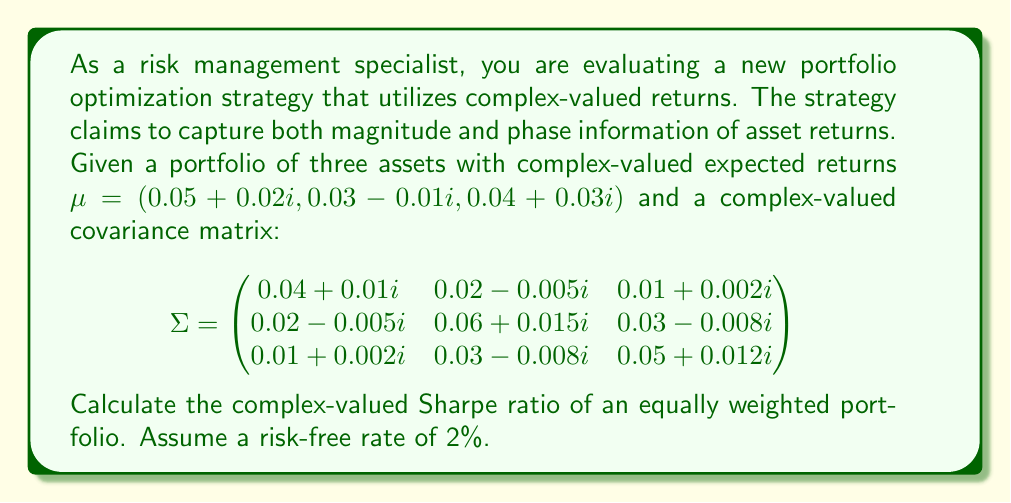Can you answer this question? To solve this problem, we'll follow these steps:

1) First, let's recall the formula for the complex-valued Sharpe ratio:

   $SR = \frac{E[R_p] - R_f}{\sqrt{Var[R_p]}}$

   Where $E[R_p]$ is the expected return of the portfolio, $R_f$ is the risk-free rate, and $Var[R_p]$ is the variance of the portfolio.

2) For an equally weighted portfolio of three assets, the weights are $w = (\frac{1}{3}, \frac{1}{3}, \frac{1}{3})$.

3) Calculate the expected return of the portfolio:
   
   $E[R_p] = w^T \mu = \frac{1}{3}(0.05 + 0.02i) + \frac{1}{3}(0.03 - 0.01i) + \frac{1}{3}(0.04 + 0.03i)$
   
   $E[R_p] = 0.04 + 0.0133i$

4) Calculate the variance of the portfolio:
   
   $Var[R_p] = w^T \Sigma w$

   $Var[R_p] = [\frac{1}{3}, \frac{1}{3}, \frac{1}{3}] \begin{pmatrix}
   0.04 + 0.01i & 0.02 - 0.005i & 0.01 + 0.002i \\
   0.02 - 0.005i & 0.06 + 0.015i & 0.03 - 0.008i \\
   0.01 + 0.002i & 0.03 - 0.008i & 0.05 + 0.012i
   \end{pmatrix} [\frac{1}{3}, \frac{1}{3}, \frac{1}{3}]^T$

   After matrix multiplication:
   
   $Var[R_p] = 0.0311 + 0.0054i$

5) Calculate the complex-valued Sharpe ratio:

   $SR = \frac{(0.04 + 0.0133i) - 0.02}{\sqrt{0.0311 + 0.0054i}}$

   $SR = \frac{0.02 + 0.0133i}{\sqrt{0.0311 + 0.0054i}}$

6) To compute the square root of a complex number $a + bi$, we can use the formula:

   $\sqrt{a + bi} = \sqrt{\frac{\sqrt{a^2 + b^2} + a}{2}} + i \cdot sign(b) \cdot \sqrt{\frac{\sqrt{a^2 + b^2} - a}{2}}$

   Applying this to our variance:

   $\sqrt{0.0311 + 0.0054i} \approx 0.1765 + 0.0153i$

7) Finally, we can compute the complex-valued Sharpe ratio:

   $SR = \frac{0.02 + 0.0133i}{0.1765 + 0.0153i}$

   To divide complex numbers, we multiply by the complex conjugate of the denominator:

   $SR = \frac{(0.02 + 0.0133i)(0.1765 - 0.0153i)}{(0.1765 + 0.0153i)(0.1765 - 0.0153i)}$

   $SR \approx 0.1089 + 0.0736i$
Answer: The complex-valued Sharpe ratio of the equally weighted portfolio is approximately $0.1089 + 0.0736i$. 